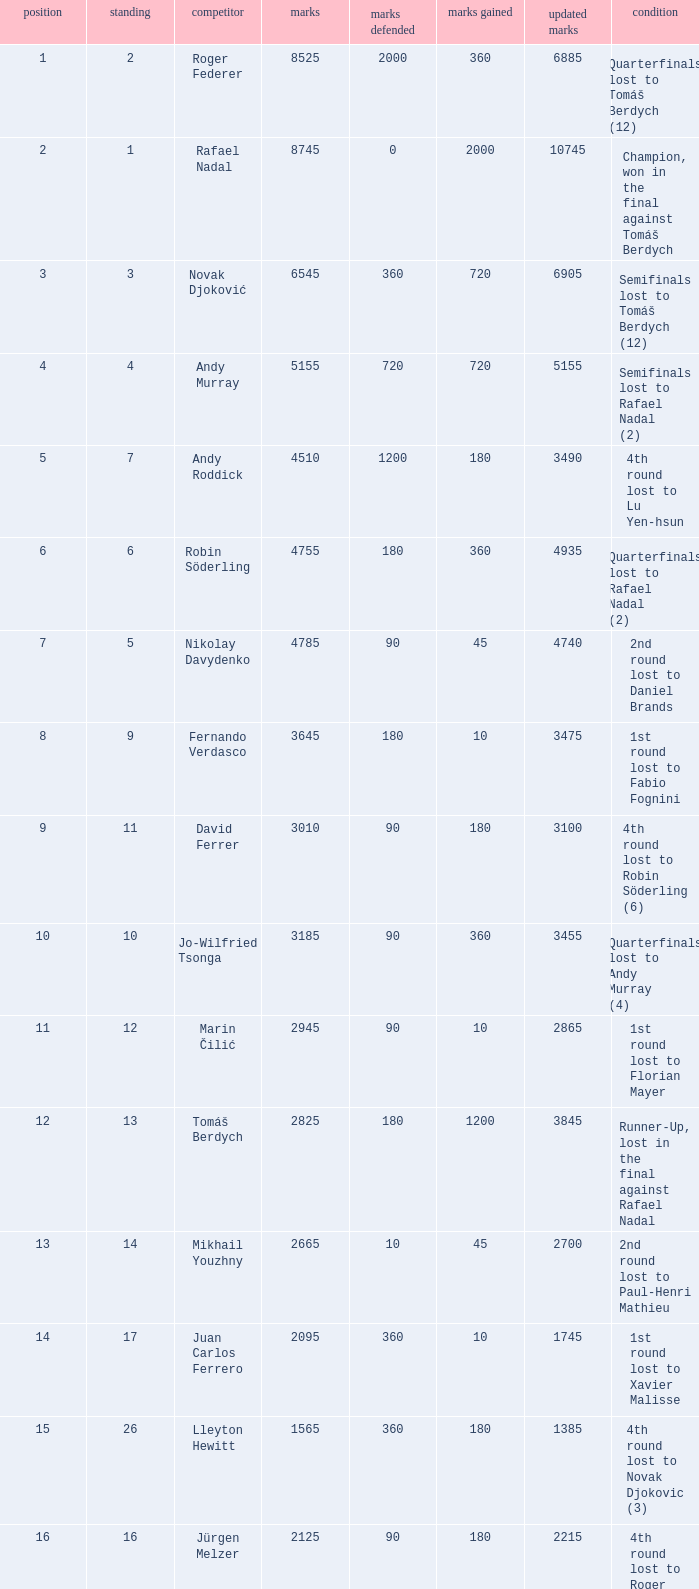Name the points won for 1230 90.0. 